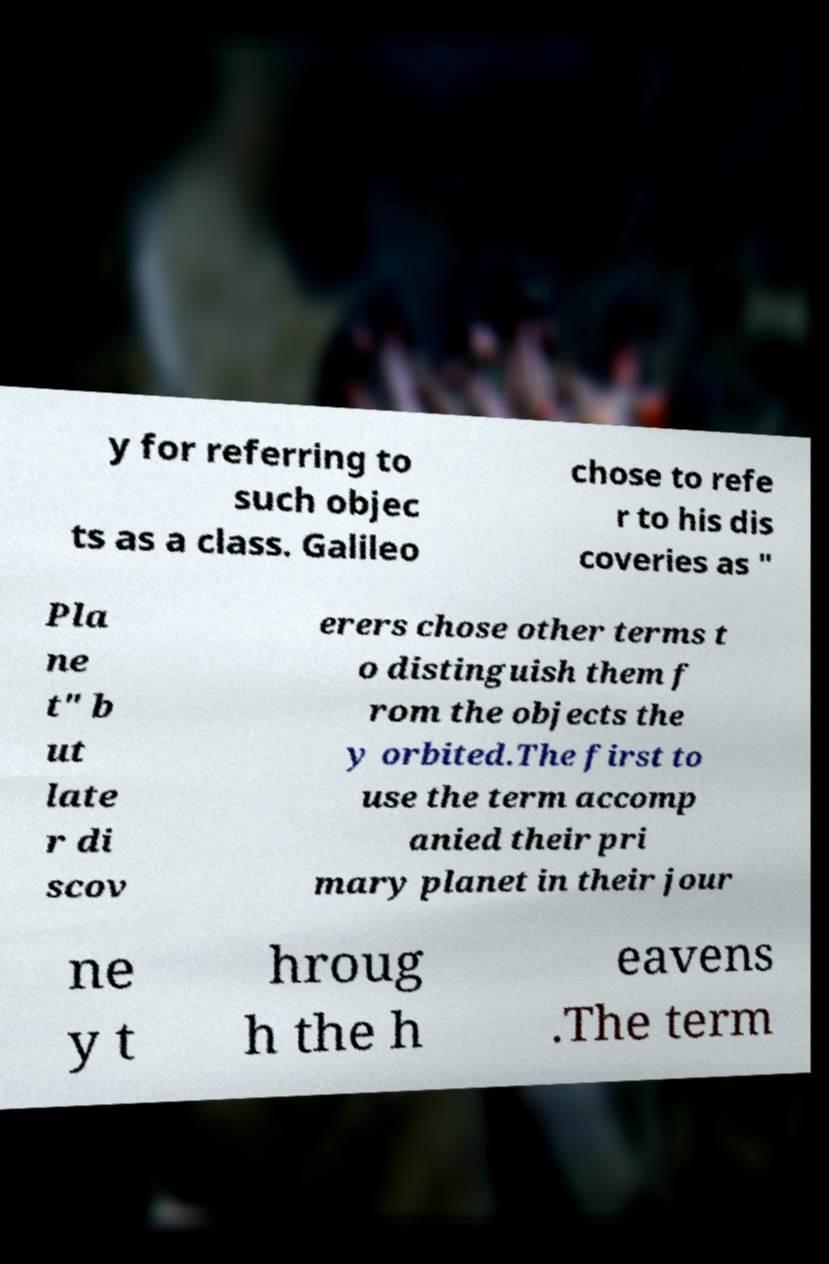Can you read and provide the text displayed in the image?This photo seems to have some interesting text. Can you extract and type it out for me? y for referring to such objec ts as a class. Galileo chose to refe r to his dis coveries as " Pla ne t" b ut late r di scov erers chose other terms t o distinguish them f rom the objects the y orbited.The first to use the term accomp anied their pri mary planet in their jour ne y t hroug h the h eavens .The term 